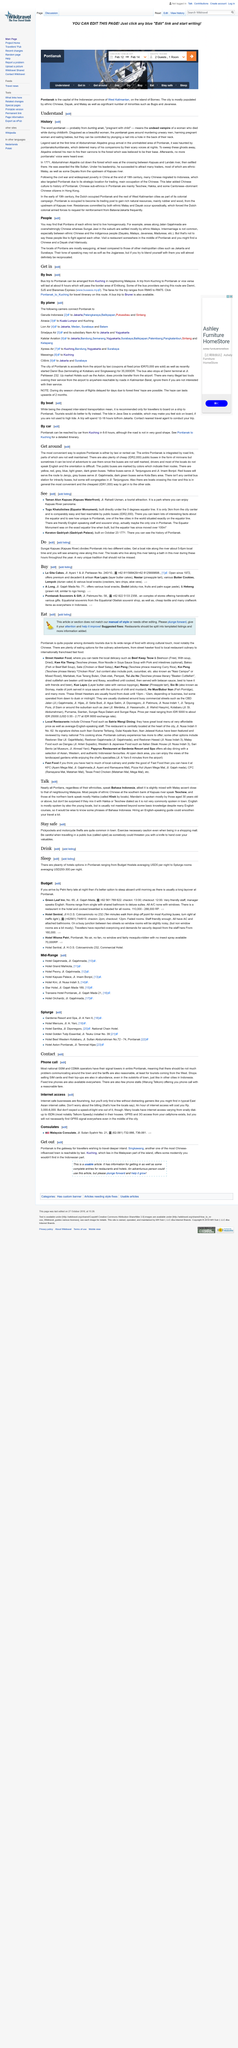Outline some significant characteristics in this image. It is proposed that the pontianak be stopped by controlling them through the implementation of a method involving the insertion of a nail into a hole in the back of their neck. The word "pontianak" likely originates from the phrase "bunting anak," meaning "pregnant with child," according to sources. The word "pontianak" refers to an undead vampire of a woman who died during childbirth. 